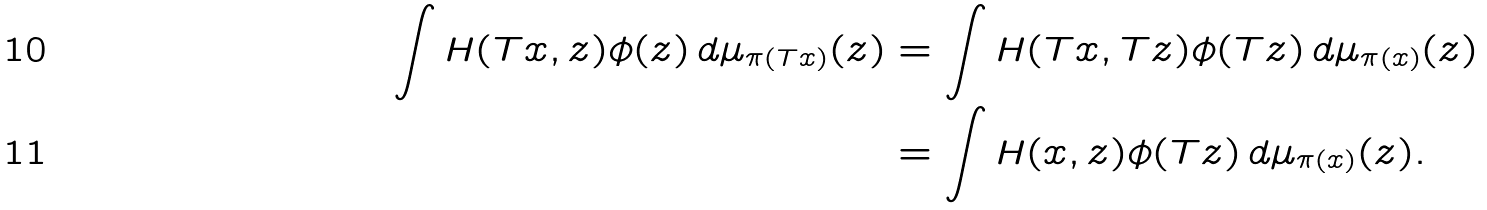<formula> <loc_0><loc_0><loc_500><loc_500>\int H ( T x , z ) \phi ( z ) \, d \mu _ { \pi ( T x ) } ( z ) & = \int H ( T x , T z ) \phi ( T z ) \, d \mu _ { \pi ( x ) } ( z ) \\ & = \int H ( x , z ) \phi ( T z ) \, d \mu _ { \pi ( x ) } ( z ) .</formula> 